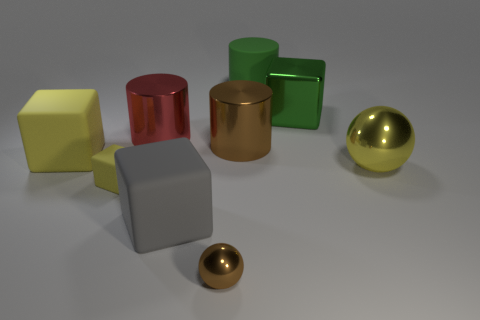The large metallic block has what color?
Offer a terse response. Green. Is there any other thing that has the same material as the gray cube?
Your response must be concise. Yes. There is a metal cylinder behind the brown shiny thing that is behind the shiny ball to the right of the large green shiny object; what is its size?
Your response must be concise. Large. There is a block that is both left of the red metallic cylinder and in front of the yellow metallic ball; what size is it?
Make the answer very short. Small. There is a object that is on the left side of the small yellow object; does it have the same color as the sphere behind the gray matte cube?
Offer a very short reply. Yes. How many gray cubes are behind the big gray thing?
Your answer should be very brief. 0. There is a brown object to the right of the brown object in front of the small rubber object; is there a tiny yellow thing behind it?
Your answer should be compact. No. What number of gray things are the same size as the yellow metal sphere?
Offer a very short reply. 1. There is a yellow object that is behind the metal ball that is to the right of the green shiny thing; what is its material?
Keep it short and to the point. Rubber. The metallic object that is to the right of the large green thing in front of the large green matte cylinder behind the tiny brown object is what shape?
Ensure brevity in your answer.  Sphere. 